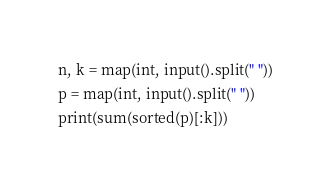<code> <loc_0><loc_0><loc_500><loc_500><_Python_>n, k = map(int, input().split(" "))
p = map(int, input().split(" "))
print(sum(sorted(p)[:k]))</code> 